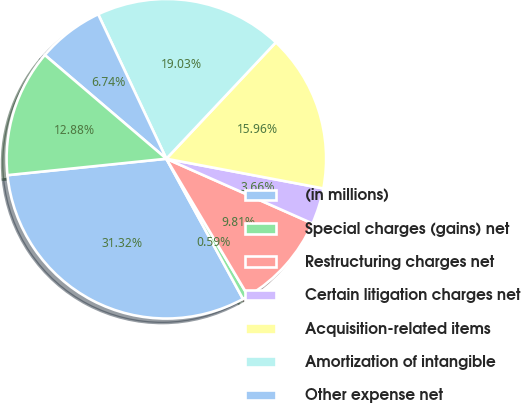Convert chart. <chart><loc_0><loc_0><loc_500><loc_500><pie_chart><fcel>(in millions)<fcel>Special charges (gains) net<fcel>Restructuring charges net<fcel>Certain litigation charges net<fcel>Acquisition-related items<fcel>Amortization of intangible<fcel>Other expense net<fcel>Interest expense net<nl><fcel>31.32%<fcel>0.59%<fcel>9.81%<fcel>3.66%<fcel>15.96%<fcel>19.03%<fcel>6.74%<fcel>12.88%<nl></chart> 